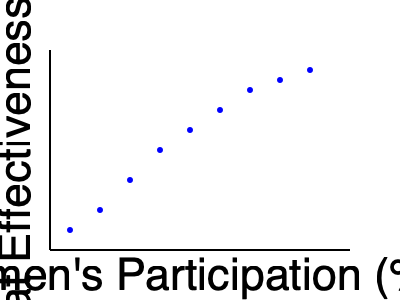Based on the scatter plot showing the relationship between women's participation in the military and overall combat effectiveness, what type of correlation is evident, and how might this inform policy decisions regarding gender integration in armed forces? To answer this question, we need to analyze the scatter plot and interpret its implications:

1. Observe the trend: As we move from left to right (increasing women's participation), the points generally move upward (increasing combat effectiveness score).

2. Identify the correlation: This upward trend indicates a positive correlation between women's participation and combat effectiveness.

3. Assess the strength: The correlation appears to be strong, as the points form a fairly consistent pattern with little scatter.

4. Consider the implications:
   a) The positive correlation suggests that increased women's participation is associated with higher combat effectiveness.
   b) This challenges traditional notions that women's involvement might decrease military effectiveness.
   c) The relationship appears to be non-linear, with a steeper increase at lower participation levels, then leveling off somewhat at higher levels.

5. Policy implications:
   a) This data supports arguments for increased gender integration in the military.
   b) It suggests that policies promoting women's participation could potentially enhance overall combat effectiveness.
   c) However, policymakers should consider the apparent diminishing returns at higher participation levels.

6. Limitations to consider:
   a) Correlation does not imply causation; other factors might influence both variables.
   b) The specific context of this data (e.g., type of military operations, time period) is not provided and could affect interpretation.

In conclusion, the scatter plot shows a strong positive correlation between women's participation and combat effectiveness, which could support policies favoring increased gender integration in the military, while acknowledging potential complexities in the relationship.
Answer: Strong positive correlation; supports increased gender integration policies with consideration of potential diminishing returns at higher participation levels. 